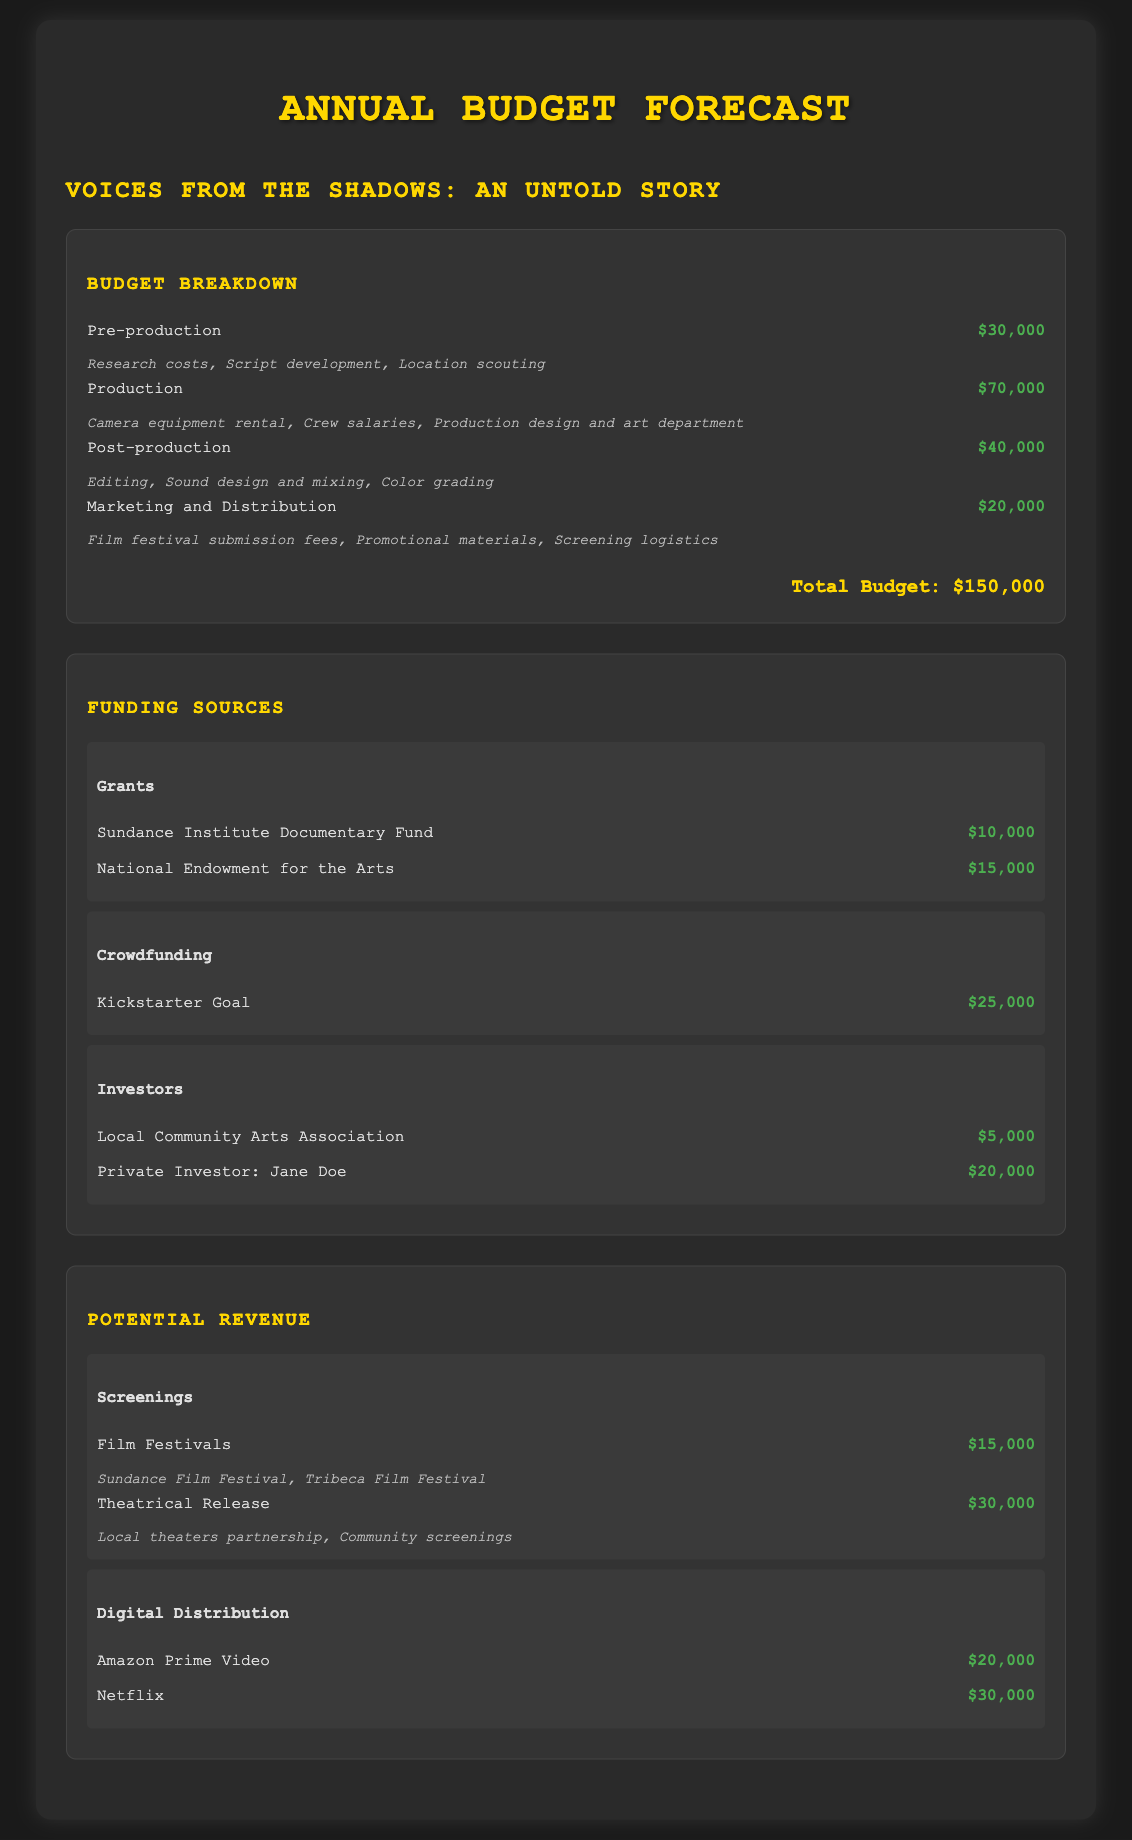What is the total budget? The total budget is clearly stated in the document as $150,000.
Answer: $150,000 How much is allocated for production? The amount allocated for production is specified in the budget breakdown as $70,000.
Answer: $70,000 Which grant provides $15,000? In the funding sources section, the National Endowment for the Arts is listed with an amount of $15,000.
Answer: National Endowment for the Arts What is the crowdfunding goal? The crowdfunding section mentions a Kickstarter goal totaling $25,000.
Answer: $25,000 How much revenue is projected from Netflix? The digital distribution section indicates that the projected revenue from Netflix is $30,000.
Answer: $30,000 What is the total amount from grants? The total amount from grants is the sum of Sundance Institute Documentary Fund and National Endowment for the Arts, which equals $25,000.
Answer: $25,000 What percentage of the total budget is allocated to marketing and distribution? Marketing and Distribution is allocated $20,000, which is a specific percentage of the total budget ($150,000).
Answer: 13.33% What is the expected revenue from film festivals? The document states the expected revenue from film festivals amounts to $15,000.
Answer: $15,000 Which funding source has the highest amount? The Private Investor: Jane Doe is the funding source with the highest listed amount of $20,000.
Answer: Private Investor: Jane Doe 